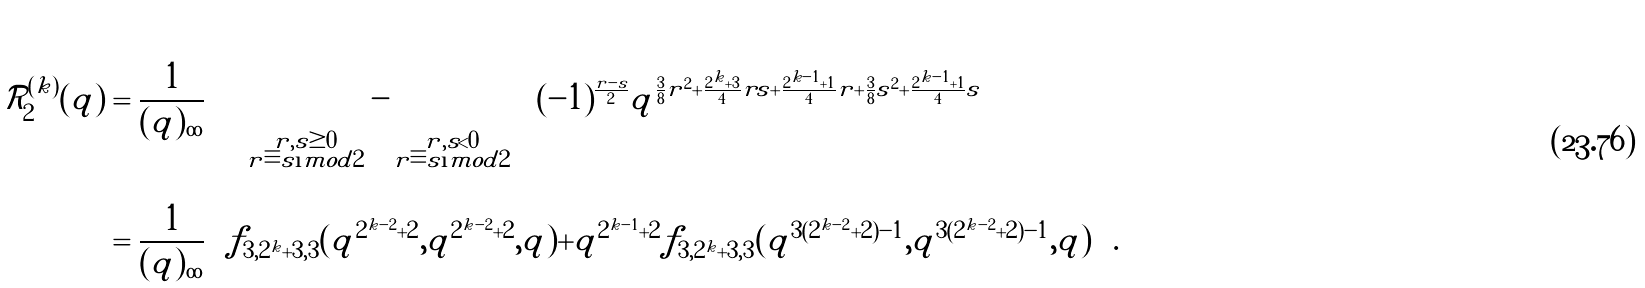<formula> <loc_0><loc_0><loc_500><loc_500>\mathcal { R } _ { 2 } ^ { ( k ) } ( q ) & = \frac { 1 } { ( q ) _ { \infty } } \left ( \left ( \sum _ { \substack { r , s \geq 0 \\ r \equiv s \i m o d { 2 } } } - \sum _ { \substack { r , s < 0 \\ r \equiv s \i m o d { 2 } } } \right ) ( - 1 ) ^ { \frac { r - s } { 2 } } q ^ { \frac { 3 } { 8 } r ^ { 2 } + \frac { 2 ^ { k } + 3 } { 4 } r s + \frac { 2 ^ { k - 1 } + 1 } { 4 } r + \frac { 3 } { 8 } s ^ { 2 } + \frac { 2 ^ { k - 1 } + 1 } { 4 } s } \right ) \\ & = \frac { 1 } { ( q ) _ { \infty } } \left ( f _ { 3 , 2 ^ { k } + 3 , 3 } ( q ^ { 2 ^ { k - 2 } + 2 } , q ^ { 2 ^ { k - 2 } + 2 } , q ) + q ^ { 2 ^ { k - 1 } + 2 } f _ { 3 , 2 ^ { k } + 3 , 3 } ( q ^ { 3 ( 2 ^ { k - 2 } + 2 ) - 1 } , q ^ { 3 ( 2 ^ { k - 2 } + 2 ) - 1 } , q ) \right ) .</formula> 